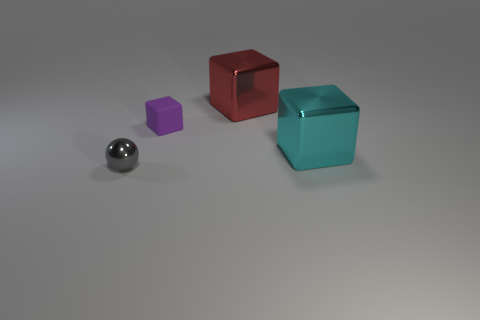Add 2 blocks. How many objects exist? 6 Subtract all blocks. How many objects are left? 1 Add 2 big blue objects. How many big blue objects exist? 2 Subtract 0 gray blocks. How many objects are left? 4 Subtract all cyan blocks. Subtract all tiny gray things. How many objects are left? 2 Add 2 small metallic things. How many small metallic things are left? 3 